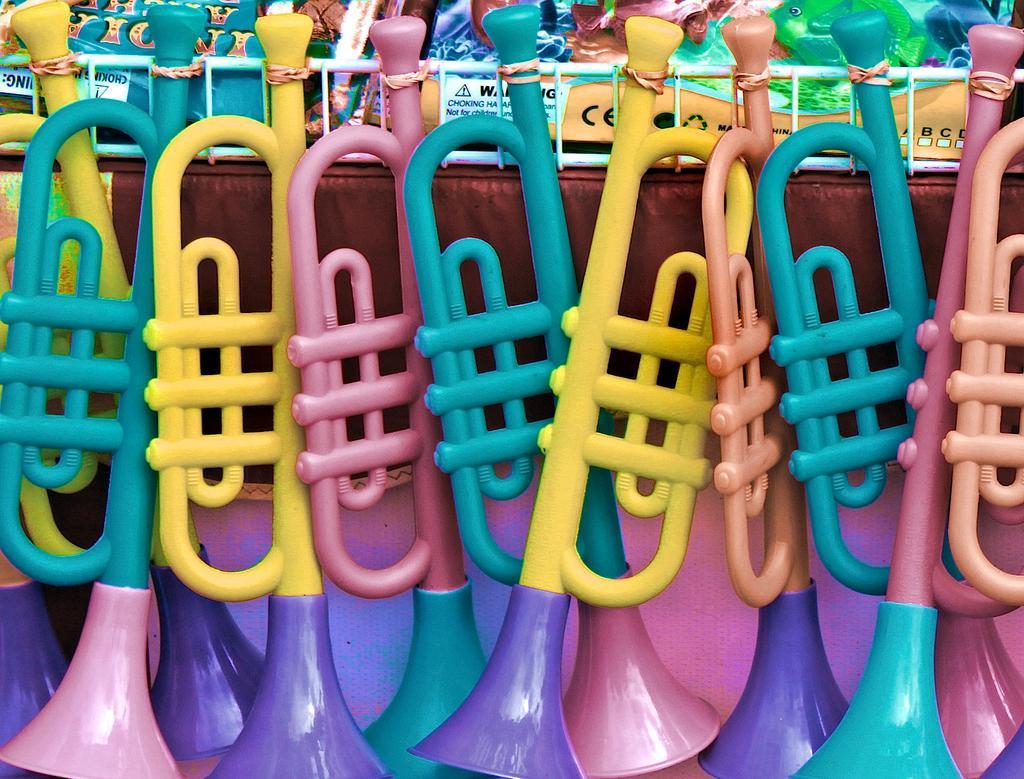How would you summarize this image in a sentence or two? In this image there are a few toys. 